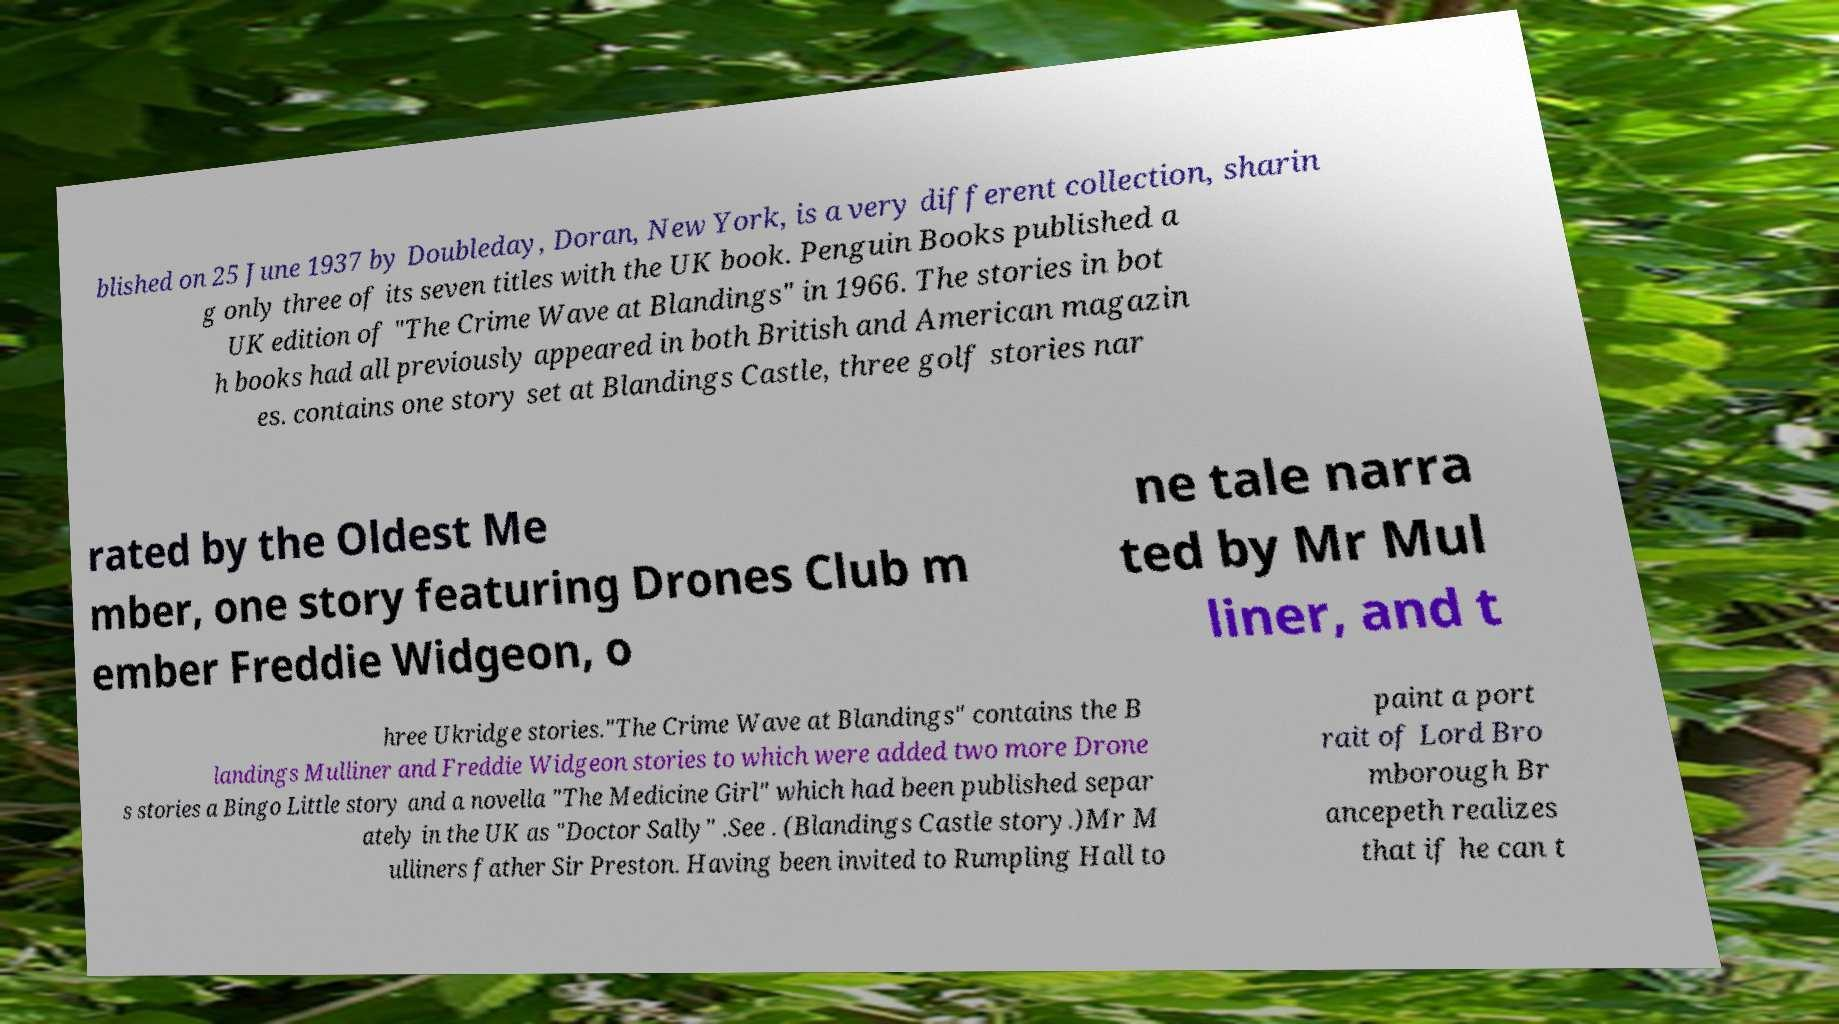Could you assist in decoding the text presented in this image and type it out clearly? blished on 25 June 1937 by Doubleday, Doran, New York, is a very different collection, sharin g only three of its seven titles with the UK book. Penguin Books published a UK edition of "The Crime Wave at Blandings" in 1966. The stories in bot h books had all previously appeared in both British and American magazin es. contains one story set at Blandings Castle, three golf stories nar rated by the Oldest Me mber, one story featuring Drones Club m ember Freddie Widgeon, o ne tale narra ted by Mr Mul liner, and t hree Ukridge stories."The Crime Wave at Blandings" contains the B landings Mulliner and Freddie Widgeon stories to which were added two more Drone s stories a Bingo Little story and a novella "The Medicine Girl" which had been published separ ately in the UK as "Doctor Sally" .See . (Blandings Castle story.)Mr M ulliners father Sir Preston. Having been invited to Rumpling Hall to paint a port rait of Lord Bro mborough Br ancepeth realizes that if he can t 